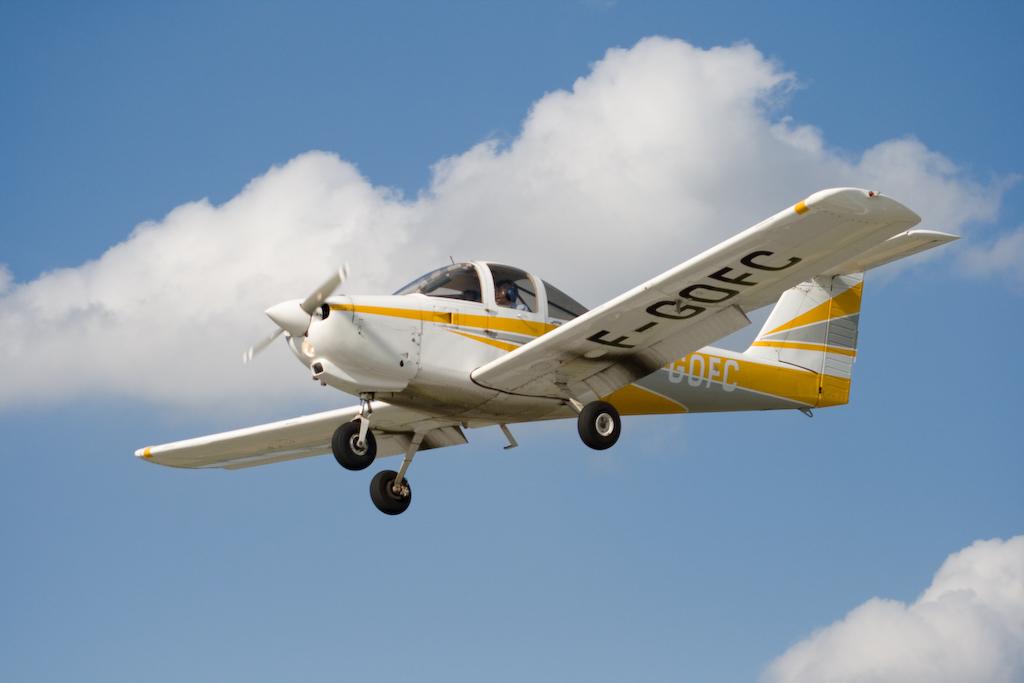What letter comes before the dash on the code under the wing?
Offer a very short reply. F. 